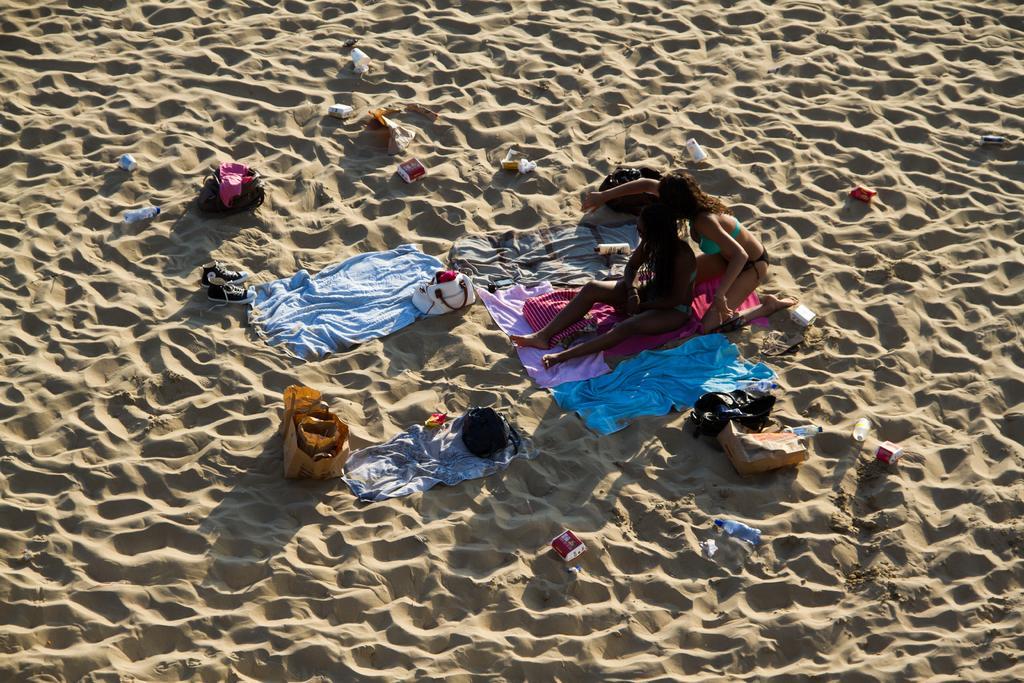In one or two sentences, can you explain what this image depicts? In this image I can see few people, colorful clothes, bags and few objects on the sand. 